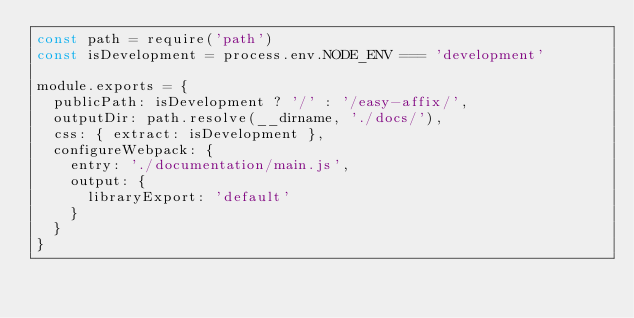<code> <loc_0><loc_0><loc_500><loc_500><_JavaScript_>const path = require('path')
const isDevelopment = process.env.NODE_ENV === 'development'

module.exports = {
  publicPath: isDevelopment ? '/' : '/easy-affix/',
  outputDir: path.resolve(__dirname, './docs/'),
  css: { extract: isDevelopment },
  configureWebpack: {
    entry: './documentation/main.js',
    output: {
      libraryExport: 'default'
    }
  }
}
</code> 